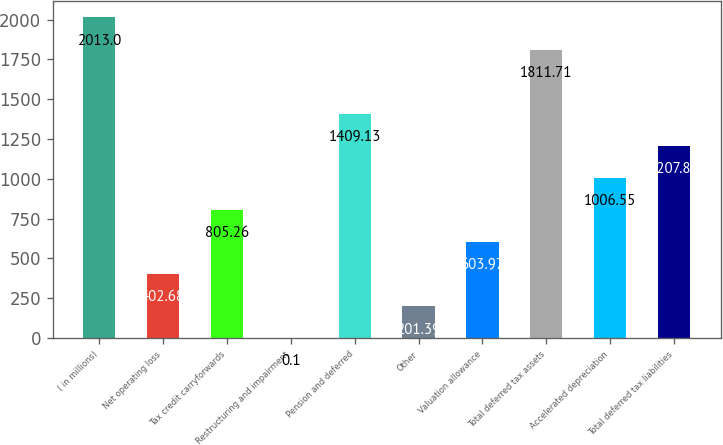Convert chart. <chart><loc_0><loc_0><loc_500><loc_500><bar_chart><fcel>( in millions)<fcel>Net operating loss<fcel>Tax credit carryforwards<fcel>Restructuring and impairment<fcel>Pension and deferred<fcel>Other<fcel>Valuation allowance<fcel>Total deferred tax assets<fcel>Accelerated depreciation<fcel>Total deferred tax liabilities<nl><fcel>2013<fcel>402.68<fcel>805.26<fcel>0.1<fcel>1409.13<fcel>201.39<fcel>603.97<fcel>1811.71<fcel>1006.55<fcel>1207.84<nl></chart> 